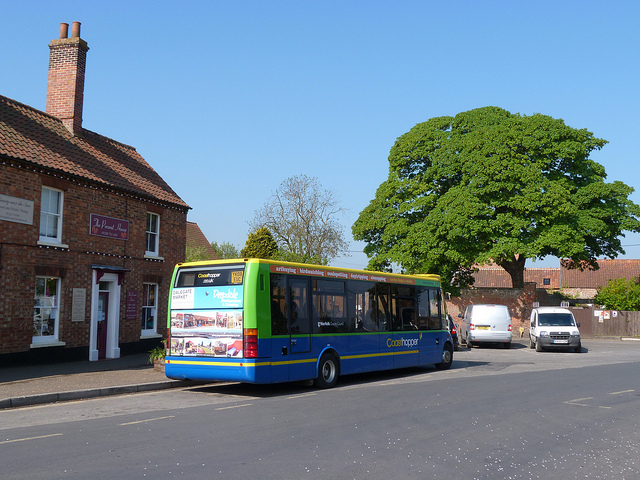Read and extract the text from this image. Cooshopper 